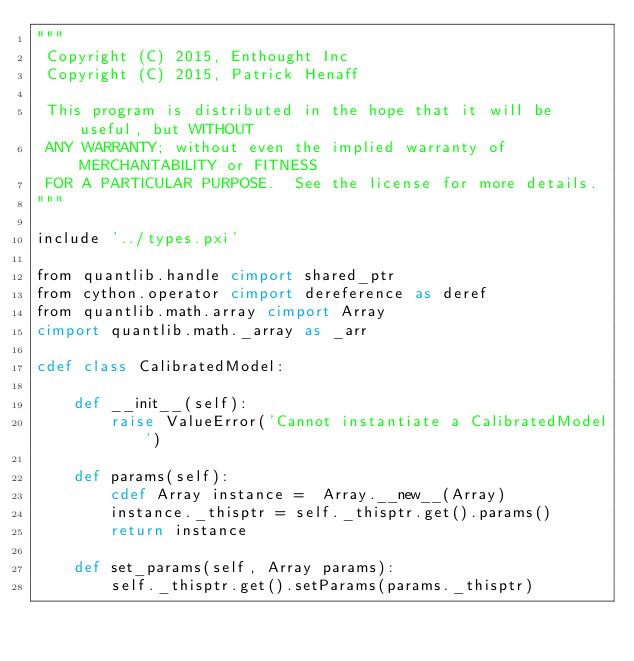Convert code to text. <code><loc_0><loc_0><loc_500><loc_500><_Cython_>"""
 Copyright (C) 2015, Enthought Inc
 Copyright (C) 2015, Patrick Henaff

 This program is distributed in the hope that it will be useful, but WITHOUT
 ANY WARRANTY; without even the implied warranty of MERCHANTABILITY or FITNESS
 FOR A PARTICULAR PURPOSE.  See the license for more details.
"""

include '../types.pxi'

from quantlib.handle cimport shared_ptr
from cython.operator cimport dereference as deref
from quantlib.math.array cimport Array
cimport quantlib.math._array as _arr

cdef class CalibratedModel:

    def __init__(self):
        raise ValueError('Cannot instantiate a CalibratedModel')

    def params(self):
        cdef Array instance =  Array.__new__(Array)
        instance._thisptr = self._thisptr.get().params()
        return instance

    def set_params(self, Array params):
        self._thisptr.get().setParams(params._thisptr)
</code> 